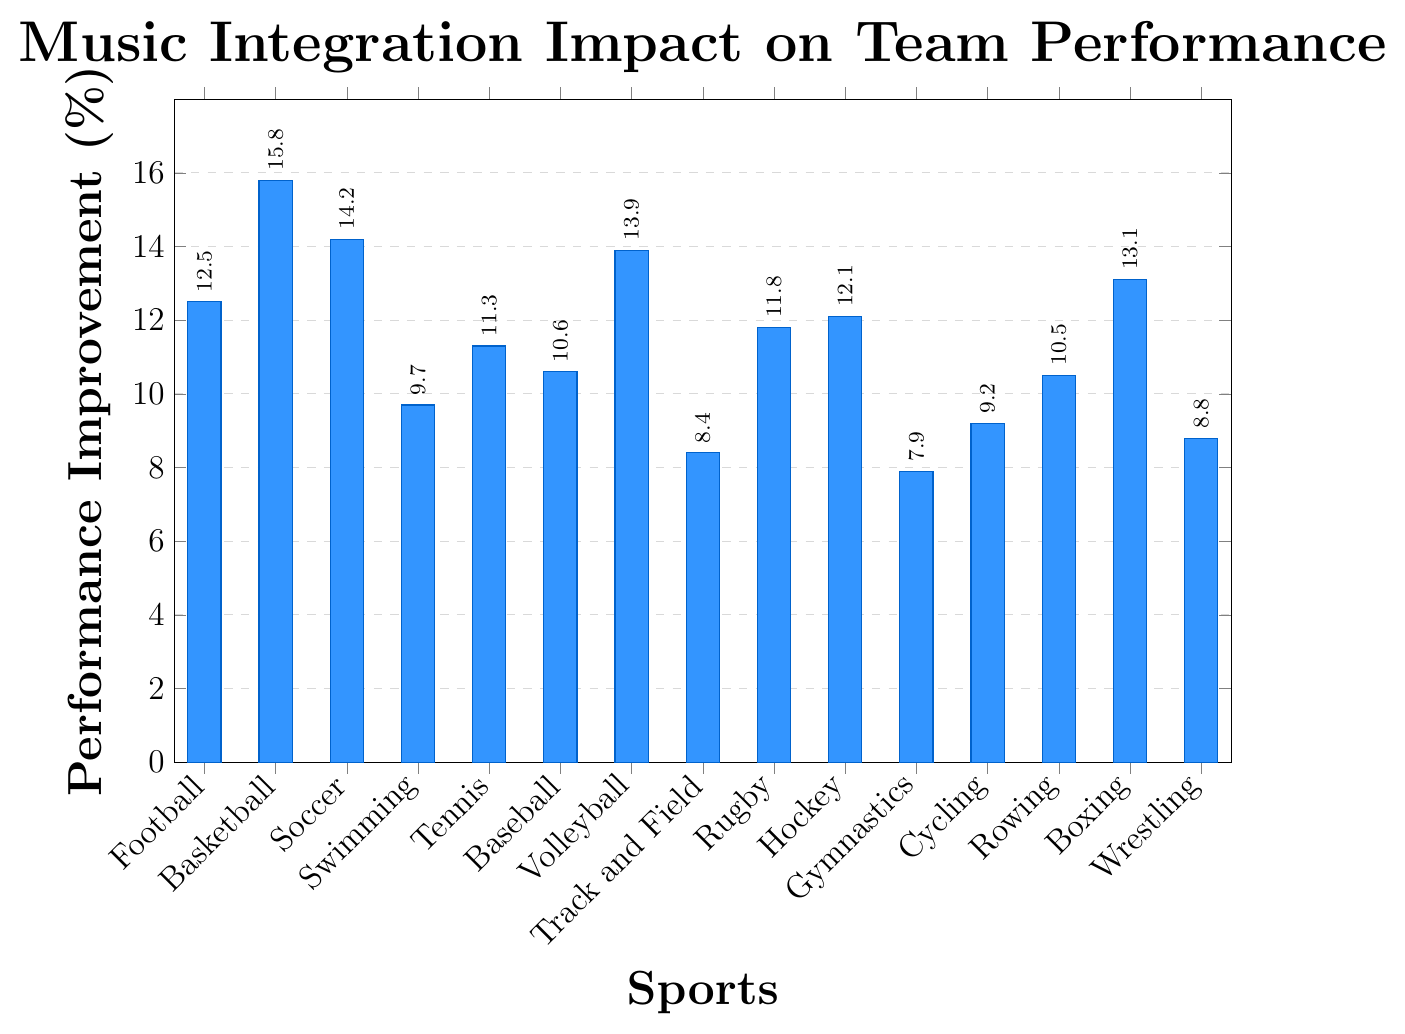Which sport shows the highest performance improvement with music integration? The bar chart displays the performance improvement percentages for each sport. Basketball has the highest bar, indicating the greatest improvement.
Answer: Basketball Which sport has the lowest performance improvement with music integration? The bar chart shows that Gymnastics has the shortest bar, indicating the lowest improvement percentage.
Answer: Gymnastics What's the difference in performance improvement between Soccer and Track and Field? The performance improvement for Soccer is 14.2% and for Track and Field is 8.4%. The difference is 14.2 - 8.4 = 5.8%.
Answer: 5.8% Which two sports have performance improvements closest to each other? Based on visual inspection, Rugby (11.8%) and Hockey (12.1%) have close performance improvement values. The difference is minimal.
Answer: Rugby and Hockey What's the average performance improvement across all sports? First, sum all the improvement percentages: 12.5 + 15.8 + 14.2 + 9.7 + 11.3 + 10.6 + 13.9 + 8.4 + 11.8 + 12.1 + 7.9 + 9.2 + 10.5 + 13.1 + 8.8 = 169.8. There are 15 sports, so the average is 169.8 / 15 = 11.32%.
Answer: 11.32% How many sports have a performance improvement of at least 12%? From the chart, the sports listed with at least 12% improvement are Football, Basketball, Soccer, Volleyball, Hockey, and Boxing, giving a total of 6 sports.
Answer: 6 Is the performance improvement for Baseball greater than the average performance improvement? The average improvement is 11.32%. Baseball has an improvement of 10.6%, which is less than the average.
Answer: No Which sports exceeded a 10% performance improvement but did not reach 12%? Sports with performance improvements between 10% and 12% are Tennis, Baseball, and Rugby.
Answer: Tennis, Baseball, Rugby What's the combined performance improvement percentage for the top 3 sports? The top 3 sports based on improvement are Basketball (15.8%), Soccer (14.2%), and Volleyball (13.9%). Their combined improvement is 15.8 + 14.2 + 13.9 = 43.9%.
Answer: 43.9% What’s the median performance improvement for all the sports listed? The performance improvements sorted are: 7.9, 8.4, 8.8, 9.2, 9.7, 10.5, 10.6, 11.3, 11.8, 12.1, 12.5, 13.1, 13.9, 14.2, 15.8. The median is the middle value, which is 11.3% (since there are 15 values).
Answer: 11.3% 